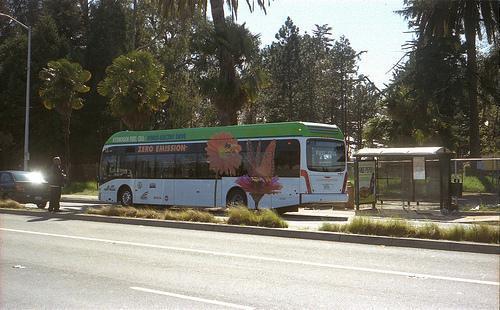How many cars are present?
Give a very brief answer. 1. 